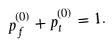<formula> <loc_0><loc_0><loc_500><loc_500>p _ { f } ^ { ( 0 ) } + p _ { t } ^ { ( 0 ) } = 1 .</formula> 